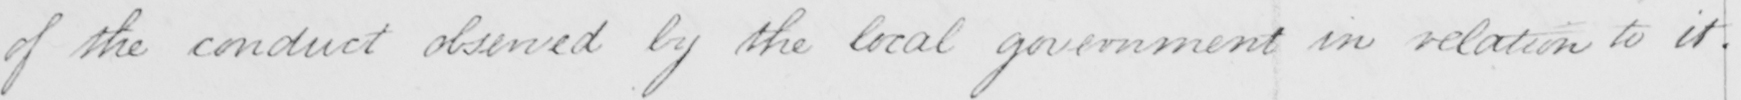Please transcribe the handwritten text in this image. of the conduct observed by the local government in relation to it . 